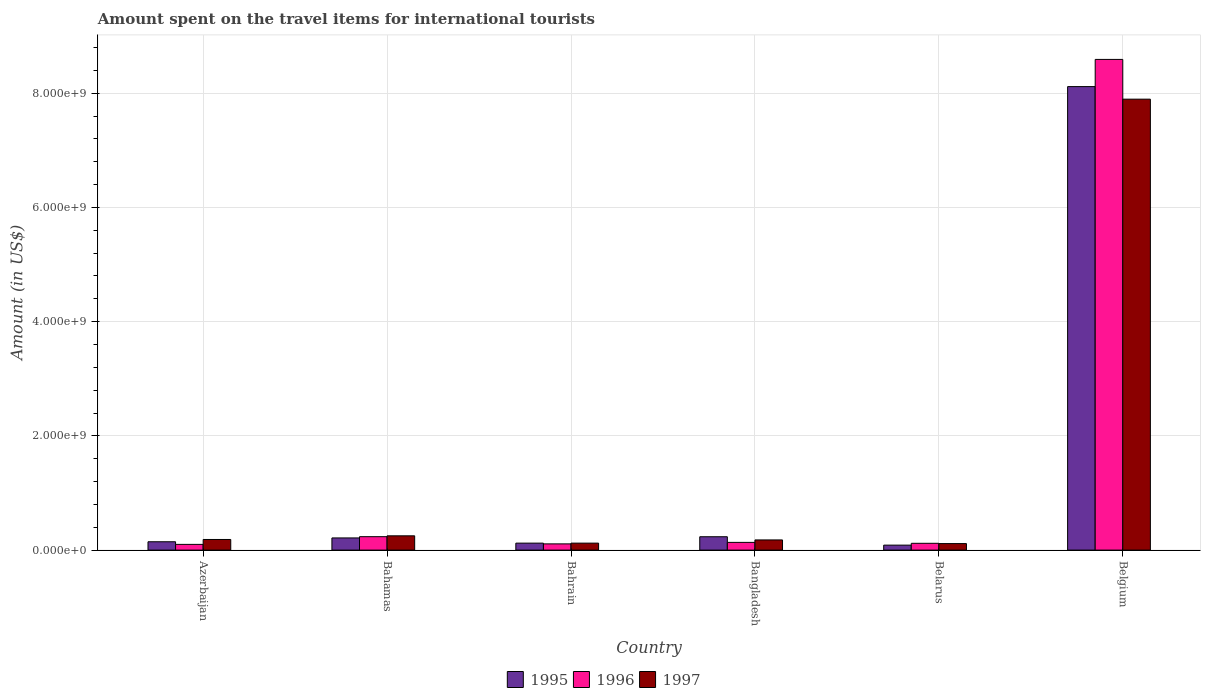How many different coloured bars are there?
Your answer should be very brief. 3. How many bars are there on the 4th tick from the right?
Keep it short and to the point. 3. What is the label of the 4th group of bars from the left?
Keep it short and to the point. Bangladesh. What is the amount spent on the travel items for international tourists in 1996 in Bahrain?
Your response must be concise. 1.09e+08. Across all countries, what is the maximum amount spent on the travel items for international tourists in 1997?
Offer a terse response. 7.90e+09. Across all countries, what is the minimum amount spent on the travel items for international tourists in 1995?
Offer a very short reply. 8.70e+07. In which country was the amount spent on the travel items for international tourists in 1997 maximum?
Give a very brief answer. Belgium. In which country was the amount spent on the travel items for international tourists in 1997 minimum?
Your answer should be very brief. Belarus. What is the total amount spent on the travel items for international tourists in 1996 in the graph?
Keep it short and to the point. 9.29e+09. What is the difference between the amount spent on the travel items for international tourists in 1997 in Bahamas and that in Belgium?
Your response must be concise. -7.64e+09. What is the difference between the amount spent on the travel items for international tourists in 1995 in Belarus and the amount spent on the travel items for international tourists in 1997 in Bangladesh?
Your answer should be compact. -9.10e+07. What is the average amount spent on the travel items for international tourists in 1997 per country?
Your answer should be very brief. 1.46e+09. What is the difference between the amount spent on the travel items for international tourists of/in 1995 and amount spent on the travel items for international tourists of/in 1997 in Belgium?
Provide a succinct answer. 2.20e+08. In how many countries, is the amount spent on the travel items for international tourists in 1996 greater than 2000000000 US$?
Offer a very short reply. 1. What is the ratio of the amount spent on the travel items for international tourists in 1996 in Bahrain to that in Belarus?
Provide a short and direct response. 0.92. What is the difference between the highest and the second highest amount spent on the travel items for international tourists in 1997?
Provide a succinct answer. 7.71e+09. What is the difference between the highest and the lowest amount spent on the travel items for international tourists in 1996?
Make the answer very short. 8.49e+09. How many bars are there?
Ensure brevity in your answer.  18. Are all the bars in the graph horizontal?
Ensure brevity in your answer.  No. What is the difference between two consecutive major ticks on the Y-axis?
Ensure brevity in your answer.  2.00e+09. Are the values on the major ticks of Y-axis written in scientific E-notation?
Make the answer very short. Yes. Does the graph contain any zero values?
Offer a terse response. No. What is the title of the graph?
Your response must be concise. Amount spent on the travel items for international tourists. Does "2003" appear as one of the legend labels in the graph?
Provide a succinct answer. No. What is the label or title of the Y-axis?
Ensure brevity in your answer.  Amount (in US$). What is the Amount (in US$) of 1995 in Azerbaijan?
Make the answer very short. 1.46e+08. What is the Amount (in US$) in 1997 in Azerbaijan?
Ensure brevity in your answer.  1.86e+08. What is the Amount (in US$) in 1995 in Bahamas?
Provide a short and direct response. 2.13e+08. What is the Amount (in US$) in 1996 in Bahamas?
Your answer should be very brief. 2.35e+08. What is the Amount (in US$) of 1997 in Bahamas?
Offer a very short reply. 2.50e+08. What is the Amount (in US$) of 1995 in Bahrain?
Offer a terse response. 1.22e+08. What is the Amount (in US$) of 1996 in Bahrain?
Give a very brief answer. 1.09e+08. What is the Amount (in US$) in 1997 in Bahrain?
Provide a short and direct response. 1.22e+08. What is the Amount (in US$) in 1995 in Bangladesh?
Offer a very short reply. 2.34e+08. What is the Amount (in US$) in 1996 in Bangladesh?
Keep it short and to the point. 1.35e+08. What is the Amount (in US$) in 1997 in Bangladesh?
Your answer should be compact. 1.78e+08. What is the Amount (in US$) of 1995 in Belarus?
Your answer should be very brief. 8.70e+07. What is the Amount (in US$) of 1996 in Belarus?
Give a very brief answer. 1.19e+08. What is the Amount (in US$) in 1997 in Belarus?
Offer a terse response. 1.14e+08. What is the Amount (in US$) of 1995 in Belgium?
Your answer should be compact. 8.12e+09. What is the Amount (in US$) in 1996 in Belgium?
Give a very brief answer. 8.59e+09. What is the Amount (in US$) in 1997 in Belgium?
Your answer should be very brief. 7.90e+09. Across all countries, what is the maximum Amount (in US$) of 1995?
Provide a short and direct response. 8.12e+09. Across all countries, what is the maximum Amount (in US$) in 1996?
Your answer should be compact. 8.59e+09. Across all countries, what is the maximum Amount (in US$) of 1997?
Offer a very short reply. 7.90e+09. Across all countries, what is the minimum Amount (in US$) in 1995?
Make the answer very short. 8.70e+07. Across all countries, what is the minimum Amount (in US$) in 1996?
Your answer should be very brief. 1.00e+08. Across all countries, what is the minimum Amount (in US$) of 1997?
Make the answer very short. 1.14e+08. What is the total Amount (in US$) in 1995 in the graph?
Your answer should be very brief. 8.92e+09. What is the total Amount (in US$) in 1996 in the graph?
Provide a succinct answer. 9.29e+09. What is the total Amount (in US$) in 1997 in the graph?
Provide a succinct answer. 8.74e+09. What is the difference between the Amount (in US$) of 1995 in Azerbaijan and that in Bahamas?
Ensure brevity in your answer.  -6.70e+07. What is the difference between the Amount (in US$) of 1996 in Azerbaijan and that in Bahamas?
Provide a short and direct response. -1.35e+08. What is the difference between the Amount (in US$) in 1997 in Azerbaijan and that in Bahamas?
Give a very brief answer. -6.40e+07. What is the difference between the Amount (in US$) of 1995 in Azerbaijan and that in Bahrain?
Ensure brevity in your answer.  2.40e+07. What is the difference between the Amount (in US$) of 1996 in Azerbaijan and that in Bahrain?
Make the answer very short. -9.00e+06. What is the difference between the Amount (in US$) in 1997 in Azerbaijan and that in Bahrain?
Offer a terse response. 6.40e+07. What is the difference between the Amount (in US$) of 1995 in Azerbaijan and that in Bangladesh?
Ensure brevity in your answer.  -8.80e+07. What is the difference between the Amount (in US$) in 1996 in Azerbaijan and that in Bangladesh?
Your response must be concise. -3.50e+07. What is the difference between the Amount (in US$) of 1997 in Azerbaijan and that in Bangladesh?
Offer a terse response. 8.00e+06. What is the difference between the Amount (in US$) of 1995 in Azerbaijan and that in Belarus?
Your answer should be very brief. 5.90e+07. What is the difference between the Amount (in US$) in 1996 in Azerbaijan and that in Belarus?
Your answer should be very brief. -1.90e+07. What is the difference between the Amount (in US$) in 1997 in Azerbaijan and that in Belarus?
Your response must be concise. 7.20e+07. What is the difference between the Amount (in US$) in 1995 in Azerbaijan and that in Belgium?
Offer a terse response. -7.97e+09. What is the difference between the Amount (in US$) in 1996 in Azerbaijan and that in Belgium?
Provide a short and direct response. -8.49e+09. What is the difference between the Amount (in US$) in 1997 in Azerbaijan and that in Belgium?
Your response must be concise. -7.71e+09. What is the difference between the Amount (in US$) of 1995 in Bahamas and that in Bahrain?
Your answer should be compact. 9.10e+07. What is the difference between the Amount (in US$) of 1996 in Bahamas and that in Bahrain?
Your answer should be compact. 1.26e+08. What is the difference between the Amount (in US$) in 1997 in Bahamas and that in Bahrain?
Provide a succinct answer. 1.28e+08. What is the difference between the Amount (in US$) of 1995 in Bahamas and that in Bangladesh?
Offer a very short reply. -2.10e+07. What is the difference between the Amount (in US$) in 1996 in Bahamas and that in Bangladesh?
Your answer should be compact. 1.00e+08. What is the difference between the Amount (in US$) in 1997 in Bahamas and that in Bangladesh?
Make the answer very short. 7.20e+07. What is the difference between the Amount (in US$) in 1995 in Bahamas and that in Belarus?
Ensure brevity in your answer.  1.26e+08. What is the difference between the Amount (in US$) in 1996 in Bahamas and that in Belarus?
Ensure brevity in your answer.  1.16e+08. What is the difference between the Amount (in US$) of 1997 in Bahamas and that in Belarus?
Provide a succinct answer. 1.36e+08. What is the difference between the Amount (in US$) in 1995 in Bahamas and that in Belgium?
Give a very brief answer. -7.90e+09. What is the difference between the Amount (in US$) of 1996 in Bahamas and that in Belgium?
Your response must be concise. -8.36e+09. What is the difference between the Amount (in US$) of 1997 in Bahamas and that in Belgium?
Your response must be concise. -7.64e+09. What is the difference between the Amount (in US$) in 1995 in Bahrain and that in Bangladesh?
Your response must be concise. -1.12e+08. What is the difference between the Amount (in US$) in 1996 in Bahrain and that in Bangladesh?
Your response must be concise. -2.60e+07. What is the difference between the Amount (in US$) in 1997 in Bahrain and that in Bangladesh?
Offer a terse response. -5.60e+07. What is the difference between the Amount (in US$) in 1995 in Bahrain and that in Belarus?
Keep it short and to the point. 3.50e+07. What is the difference between the Amount (in US$) in 1996 in Bahrain and that in Belarus?
Offer a terse response. -1.00e+07. What is the difference between the Amount (in US$) of 1997 in Bahrain and that in Belarus?
Give a very brief answer. 8.00e+06. What is the difference between the Amount (in US$) in 1995 in Bahrain and that in Belgium?
Ensure brevity in your answer.  -7.99e+09. What is the difference between the Amount (in US$) in 1996 in Bahrain and that in Belgium?
Give a very brief answer. -8.48e+09. What is the difference between the Amount (in US$) of 1997 in Bahrain and that in Belgium?
Offer a terse response. -7.77e+09. What is the difference between the Amount (in US$) in 1995 in Bangladesh and that in Belarus?
Keep it short and to the point. 1.47e+08. What is the difference between the Amount (in US$) in 1996 in Bangladesh and that in Belarus?
Ensure brevity in your answer.  1.60e+07. What is the difference between the Amount (in US$) of 1997 in Bangladesh and that in Belarus?
Make the answer very short. 6.40e+07. What is the difference between the Amount (in US$) of 1995 in Bangladesh and that in Belgium?
Make the answer very short. -7.88e+09. What is the difference between the Amount (in US$) in 1996 in Bangladesh and that in Belgium?
Offer a terse response. -8.46e+09. What is the difference between the Amount (in US$) of 1997 in Bangladesh and that in Belgium?
Ensure brevity in your answer.  -7.72e+09. What is the difference between the Amount (in US$) in 1995 in Belarus and that in Belgium?
Offer a terse response. -8.03e+09. What is the difference between the Amount (in US$) in 1996 in Belarus and that in Belgium?
Make the answer very short. -8.47e+09. What is the difference between the Amount (in US$) in 1997 in Belarus and that in Belgium?
Keep it short and to the point. -7.78e+09. What is the difference between the Amount (in US$) in 1995 in Azerbaijan and the Amount (in US$) in 1996 in Bahamas?
Give a very brief answer. -8.90e+07. What is the difference between the Amount (in US$) in 1995 in Azerbaijan and the Amount (in US$) in 1997 in Bahamas?
Provide a succinct answer. -1.04e+08. What is the difference between the Amount (in US$) of 1996 in Azerbaijan and the Amount (in US$) of 1997 in Bahamas?
Ensure brevity in your answer.  -1.50e+08. What is the difference between the Amount (in US$) in 1995 in Azerbaijan and the Amount (in US$) in 1996 in Bahrain?
Your answer should be compact. 3.70e+07. What is the difference between the Amount (in US$) of 1995 in Azerbaijan and the Amount (in US$) of 1997 in Bahrain?
Your answer should be compact. 2.40e+07. What is the difference between the Amount (in US$) of 1996 in Azerbaijan and the Amount (in US$) of 1997 in Bahrain?
Give a very brief answer. -2.20e+07. What is the difference between the Amount (in US$) in 1995 in Azerbaijan and the Amount (in US$) in 1996 in Bangladesh?
Make the answer very short. 1.10e+07. What is the difference between the Amount (in US$) in 1995 in Azerbaijan and the Amount (in US$) in 1997 in Bangladesh?
Provide a succinct answer. -3.20e+07. What is the difference between the Amount (in US$) of 1996 in Azerbaijan and the Amount (in US$) of 1997 in Bangladesh?
Provide a short and direct response. -7.80e+07. What is the difference between the Amount (in US$) of 1995 in Azerbaijan and the Amount (in US$) of 1996 in Belarus?
Your answer should be compact. 2.70e+07. What is the difference between the Amount (in US$) in 1995 in Azerbaijan and the Amount (in US$) in 1997 in Belarus?
Offer a very short reply. 3.20e+07. What is the difference between the Amount (in US$) of 1996 in Azerbaijan and the Amount (in US$) of 1997 in Belarus?
Your answer should be compact. -1.40e+07. What is the difference between the Amount (in US$) of 1995 in Azerbaijan and the Amount (in US$) of 1996 in Belgium?
Your answer should be very brief. -8.44e+09. What is the difference between the Amount (in US$) of 1995 in Azerbaijan and the Amount (in US$) of 1997 in Belgium?
Provide a short and direct response. -7.75e+09. What is the difference between the Amount (in US$) of 1996 in Azerbaijan and the Amount (in US$) of 1997 in Belgium?
Offer a terse response. -7.80e+09. What is the difference between the Amount (in US$) of 1995 in Bahamas and the Amount (in US$) of 1996 in Bahrain?
Give a very brief answer. 1.04e+08. What is the difference between the Amount (in US$) in 1995 in Bahamas and the Amount (in US$) in 1997 in Bahrain?
Offer a very short reply. 9.10e+07. What is the difference between the Amount (in US$) in 1996 in Bahamas and the Amount (in US$) in 1997 in Bahrain?
Provide a succinct answer. 1.13e+08. What is the difference between the Amount (in US$) in 1995 in Bahamas and the Amount (in US$) in 1996 in Bangladesh?
Ensure brevity in your answer.  7.80e+07. What is the difference between the Amount (in US$) of 1995 in Bahamas and the Amount (in US$) of 1997 in Bangladesh?
Your response must be concise. 3.50e+07. What is the difference between the Amount (in US$) of 1996 in Bahamas and the Amount (in US$) of 1997 in Bangladesh?
Your response must be concise. 5.70e+07. What is the difference between the Amount (in US$) of 1995 in Bahamas and the Amount (in US$) of 1996 in Belarus?
Provide a short and direct response. 9.40e+07. What is the difference between the Amount (in US$) in 1995 in Bahamas and the Amount (in US$) in 1997 in Belarus?
Your answer should be compact. 9.90e+07. What is the difference between the Amount (in US$) in 1996 in Bahamas and the Amount (in US$) in 1997 in Belarus?
Keep it short and to the point. 1.21e+08. What is the difference between the Amount (in US$) in 1995 in Bahamas and the Amount (in US$) in 1996 in Belgium?
Keep it short and to the point. -8.38e+09. What is the difference between the Amount (in US$) of 1995 in Bahamas and the Amount (in US$) of 1997 in Belgium?
Your response must be concise. -7.68e+09. What is the difference between the Amount (in US$) in 1996 in Bahamas and the Amount (in US$) in 1997 in Belgium?
Offer a terse response. -7.66e+09. What is the difference between the Amount (in US$) in 1995 in Bahrain and the Amount (in US$) in 1996 in Bangladesh?
Provide a succinct answer. -1.30e+07. What is the difference between the Amount (in US$) of 1995 in Bahrain and the Amount (in US$) of 1997 in Bangladesh?
Ensure brevity in your answer.  -5.60e+07. What is the difference between the Amount (in US$) in 1996 in Bahrain and the Amount (in US$) in 1997 in Bangladesh?
Provide a succinct answer. -6.90e+07. What is the difference between the Amount (in US$) of 1995 in Bahrain and the Amount (in US$) of 1997 in Belarus?
Ensure brevity in your answer.  8.00e+06. What is the difference between the Amount (in US$) of 1996 in Bahrain and the Amount (in US$) of 1997 in Belarus?
Ensure brevity in your answer.  -5.00e+06. What is the difference between the Amount (in US$) in 1995 in Bahrain and the Amount (in US$) in 1996 in Belgium?
Provide a short and direct response. -8.47e+09. What is the difference between the Amount (in US$) of 1995 in Bahrain and the Amount (in US$) of 1997 in Belgium?
Give a very brief answer. -7.77e+09. What is the difference between the Amount (in US$) in 1996 in Bahrain and the Amount (in US$) in 1997 in Belgium?
Your answer should be compact. -7.79e+09. What is the difference between the Amount (in US$) of 1995 in Bangladesh and the Amount (in US$) of 1996 in Belarus?
Make the answer very short. 1.15e+08. What is the difference between the Amount (in US$) in 1995 in Bangladesh and the Amount (in US$) in 1997 in Belarus?
Your answer should be very brief. 1.20e+08. What is the difference between the Amount (in US$) of 1996 in Bangladesh and the Amount (in US$) of 1997 in Belarus?
Offer a terse response. 2.10e+07. What is the difference between the Amount (in US$) in 1995 in Bangladesh and the Amount (in US$) in 1996 in Belgium?
Keep it short and to the point. -8.36e+09. What is the difference between the Amount (in US$) of 1995 in Bangladesh and the Amount (in US$) of 1997 in Belgium?
Keep it short and to the point. -7.66e+09. What is the difference between the Amount (in US$) of 1996 in Bangladesh and the Amount (in US$) of 1997 in Belgium?
Ensure brevity in your answer.  -7.76e+09. What is the difference between the Amount (in US$) of 1995 in Belarus and the Amount (in US$) of 1996 in Belgium?
Provide a short and direct response. -8.50e+09. What is the difference between the Amount (in US$) in 1995 in Belarus and the Amount (in US$) in 1997 in Belgium?
Your answer should be compact. -7.81e+09. What is the difference between the Amount (in US$) in 1996 in Belarus and the Amount (in US$) in 1997 in Belgium?
Your answer should be compact. -7.78e+09. What is the average Amount (in US$) of 1995 per country?
Provide a short and direct response. 1.49e+09. What is the average Amount (in US$) of 1996 per country?
Give a very brief answer. 1.55e+09. What is the average Amount (in US$) in 1997 per country?
Offer a very short reply. 1.46e+09. What is the difference between the Amount (in US$) of 1995 and Amount (in US$) of 1996 in Azerbaijan?
Make the answer very short. 4.60e+07. What is the difference between the Amount (in US$) in 1995 and Amount (in US$) in 1997 in Azerbaijan?
Offer a very short reply. -4.00e+07. What is the difference between the Amount (in US$) of 1996 and Amount (in US$) of 1997 in Azerbaijan?
Make the answer very short. -8.60e+07. What is the difference between the Amount (in US$) in 1995 and Amount (in US$) in 1996 in Bahamas?
Offer a very short reply. -2.20e+07. What is the difference between the Amount (in US$) of 1995 and Amount (in US$) of 1997 in Bahamas?
Your answer should be compact. -3.70e+07. What is the difference between the Amount (in US$) in 1996 and Amount (in US$) in 1997 in Bahamas?
Make the answer very short. -1.50e+07. What is the difference between the Amount (in US$) in 1995 and Amount (in US$) in 1996 in Bahrain?
Make the answer very short. 1.30e+07. What is the difference between the Amount (in US$) of 1995 and Amount (in US$) of 1997 in Bahrain?
Your answer should be compact. 0. What is the difference between the Amount (in US$) of 1996 and Amount (in US$) of 1997 in Bahrain?
Give a very brief answer. -1.30e+07. What is the difference between the Amount (in US$) of 1995 and Amount (in US$) of 1996 in Bangladesh?
Offer a terse response. 9.90e+07. What is the difference between the Amount (in US$) of 1995 and Amount (in US$) of 1997 in Bangladesh?
Keep it short and to the point. 5.60e+07. What is the difference between the Amount (in US$) in 1996 and Amount (in US$) in 1997 in Bangladesh?
Your answer should be compact. -4.30e+07. What is the difference between the Amount (in US$) in 1995 and Amount (in US$) in 1996 in Belarus?
Your response must be concise. -3.20e+07. What is the difference between the Amount (in US$) of 1995 and Amount (in US$) of 1997 in Belarus?
Ensure brevity in your answer.  -2.70e+07. What is the difference between the Amount (in US$) of 1996 and Amount (in US$) of 1997 in Belarus?
Keep it short and to the point. 5.00e+06. What is the difference between the Amount (in US$) in 1995 and Amount (in US$) in 1996 in Belgium?
Make the answer very short. -4.76e+08. What is the difference between the Amount (in US$) of 1995 and Amount (in US$) of 1997 in Belgium?
Provide a short and direct response. 2.20e+08. What is the difference between the Amount (in US$) in 1996 and Amount (in US$) in 1997 in Belgium?
Provide a succinct answer. 6.96e+08. What is the ratio of the Amount (in US$) in 1995 in Azerbaijan to that in Bahamas?
Make the answer very short. 0.69. What is the ratio of the Amount (in US$) in 1996 in Azerbaijan to that in Bahamas?
Your answer should be compact. 0.43. What is the ratio of the Amount (in US$) of 1997 in Azerbaijan to that in Bahamas?
Keep it short and to the point. 0.74. What is the ratio of the Amount (in US$) of 1995 in Azerbaijan to that in Bahrain?
Keep it short and to the point. 1.2. What is the ratio of the Amount (in US$) in 1996 in Azerbaijan to that in Bahrain?
Provide a short and direct response. 0.92. What is the ratio of the Amount (in US$) of 1997 in Azerbaijan to that in Bahrain?
Ensure brevity in your answer.  1.52. What is the ratio of the Amount (in US$) of 1995 in Azerbaijan to that in Bangladesh?
Provide a short and direct response. 0.62. What is the ratio of the Amount (in US$) of 1996 in Azerbaijan to that in Bangladesh?
Provide a short and direct response. 0.74. What is the ratio of the Amount (in US$) in 1997 in Azerbaijan to that in Bangladesh?
Keep it short and to the point. 1.04. What is the ratio of the Amount (in US$) in 1995 in Azerbaijan to that in Belarus?
Provide a succinct answer. 1.68. What is the ratio of the Amount (in US$) of 1996 in Azerbaijan to that in Belarus?
Your answer should be compact. 0.84. What is the ratio of the Amount (in US$) of 1997 in Azerbaijan to that in Belarus?
Your answer should be very brief. 1.63. What is the ratio of the Amount (in US$) of 1995 in Azerbaijan to that in Belgium?
Make the answer very short. 0.02. What is the ratio of the Amount (in US$) in 1996 in Azerbaijan to that in Belgium?
Ensure brevity in your answer.  0.01. What is the ratio of the Amount (in US$) in 1997 in Azerbaijan to that in Belgium?
Provide a succinct answer. 0.02. What is the ratio of the Amount (in US$) of 1995 in Bahamas to that in Bahrain?
Give a very brief answer. 1.75. What is the ratio of the Amount (in US$) in 1996 in Bahamas to that in Bahrain?
Give a very brief answer. 2.16. What is the ratio of the Amount (in US$) in 1997 in Bahamas to that in Bahrain?
Offer a terse response. 2.05. What is the ratio of the Amount (in US$) of 1995 in Bahamas to that in Bangladesh?
Make the answer very short. 0.91. What is the ratio of the Amount (in US$) in 1996 in Bahamas to that in Bangladesh?
Offer a terse response. 1.74. What is the ratio of the Amount (in US$) of 1997 in Bahamas to that in Bangladesh?
Offer a very short reply. 1.4. What is the ratio of the Amount (in US$) of 1995 in Bahamas to that in Belarus?
Your answer should be very brief. 2.45. What is the ratio of the Amount (in US$) in 1996 in Bahamas to that in Belarus?
Your answer should be compact. 1.97. What is the ratio of the Amount (in US$) in 1997 in Bahamas to that in Belarus?
Your answer should be compact. 2.19. What is the ratio of the Amount (in US$) in 1995 in Bahamas to that in Belgium?
Your response must be concise. 0.03. What is the ratio of the Amount (in US$) in 1996 in Bahamas to that in Belgium?
Ensure brevity in your answer.  0.03. What is the ratio of the Amount (in US$) of 1997 in Bahamas to that in Belgium?
Offer a very short reply. 0.03. What is the ratio of the Amount (in US$) of 1995 in Bahrain to that in Bangladesh?
Give a very brief answer. 0.52. What is the ratio of the Amount (in US$) of 1996 in Bahrain to that in Bangladesh?
Your response must be concise. 0.81. What is the ratio of the Amount (in US$) of 1997 in Bahrain to that in Bangladesh?
Provide a short and direct response. 0.69. What is the ratio of the Amount (in US$) of 1995 in Bahrain to that in Belarus?
Offer a very short reply. 1.4. What is the ratio of the Amount (in US$) of 1996 in Bahrain to that in Belarus?
Give a very brief answer. 0.92. What is the ratio of the Amount (in US$) in 1997 in Bahrain to that in Belarus?
Your answer should be very brief. 1.07. What is the ratio of the Amount (in US$) of 1995 in Bahrain to that in Belgium?
Your answer should be compact. 0.01. What is the ratio of the Amount (in US$) in 1996 in Bahrain to that in Belgium?
Provide a short and direct response. 0.01. What is the ratio of the Amount (in US$) of 1997 in Bahrain to that in Belgium?
Give a very brief answer. 0.02. What is the ratio of the Amount (in US$) of 1995 in Bangladesh to that in Belarus?
Your answer should be compact. 2.69. What is the ratio of the Amount (in US$) of 1996 in Bangladesh to that in Belarus?
Keep it short and to the point. 1.13. What is the ratio of the Amount (in US$) in 1997 in Bangladesh to that in Belarus?
Keep it short and to the point. 1.56. What is the ratio of the Amount (in US$) in 1995 in Bangladesh to that in Belgium?
Give a very brief answer. 0.03. What is the ratio of the Amount (in US$) in 1996 in Bangladesh to that in Belgium?
Provide a short and direct response. 0.02. What is the ratio of the Amount (in US$) of 1997 in Bangladesh to that in Belgium?
Provide a short and direct response. 0.02. What is the ratio of the Amount (in US$) in 1995 in Belarus to that in Belgium?
Provide a succinct answer. 0.01. What is the ratio of the Amount (in US$) of 1996 in Belarus to that in Belgium?
Your response must be concise. 0.01. What is the ratio of the Amount (in US$) of 1997 in Belarus to that in Belgium?
Offer a terse response. 0.01. What is the difference between the highest and the second highest Amount (in US$) in 1995?
Offer a very short reply. 7.88e+09. What is the difference between the highest and the second highest Amount (in US$) in 1996?
Make the answer very short. 8.36e+09. What is the difference between the highest and the second highest Amount (in US$) in 1997?
Your answer should be very brief. 7.64e+09. What is the difference between the highest and the lowest Amount (in US$) in 1995?
Give a very brief answer. 8.03e+09. What is the difference between the highest and the lowest Amount (in US$) in 1996?
Provide a succinct answer. 8.49e+09. What is the difference between the highest and the lowest Amount (in US$) in 1997?
Give a very brief answer. 7.78e+09. 